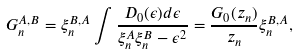Convert formula to latex. <formula><loc_0><loc_0><loc_500><loc_500>G _ { n } ^ { A , B } = \xi _ { n } ^ { B , A } \int \frac { D _ { 0 } ( \epsilon ) d \epsilon } { \xi _ { n } ^ { A } \xi _ { n } ^ { B } - { \epsilon } ^ { 2 } } = \frac { G _ { 0 } ( z _ { n } ) } { z _ { n } } \xi _ { n } ^ { B , A } ,</formula> 